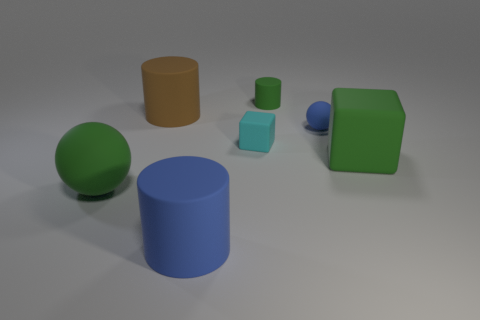Subtract all large cylinders. How many cylinders are left? 1 Add 2 small matte things. How many objects exist? 9 Subtract all spheres. How many objects are left? 5 Subtract all purple cylinders. Subtract all yellow cubes. How many cylinders are left? 3 Subtract all cyan matte objects. Subtract all large green spheres. How many objects are left? 5 Add 1 brown objects. How many brown objects are left? 2 Add 2 large red rubber balls. How many large red rubber balls exist? 2 Subtract 0 purple cubes. How many objects are left? 7 